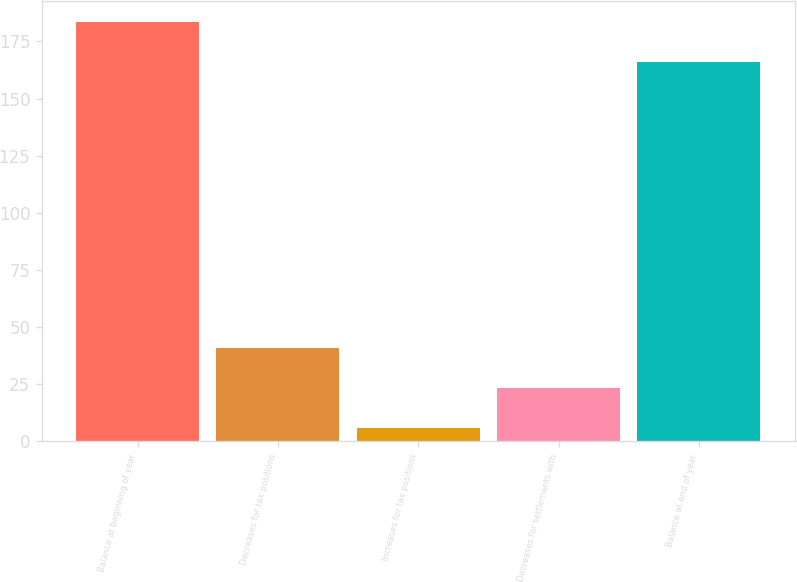Convert chart to OTSL. <chart><loc_0><loc_0><loc_500><loc_500><bar_chart><fcel>Balance at beginning of year<fcel>Decreases for tax positions<fcel>Increases for tax positions<fcel>Decreases for settlements with<fcel>Balance at end of year<nl><fcel>183.4<fcel>40.8<fcel>6<fcel>23.4<fcel>166<nl></chart> 